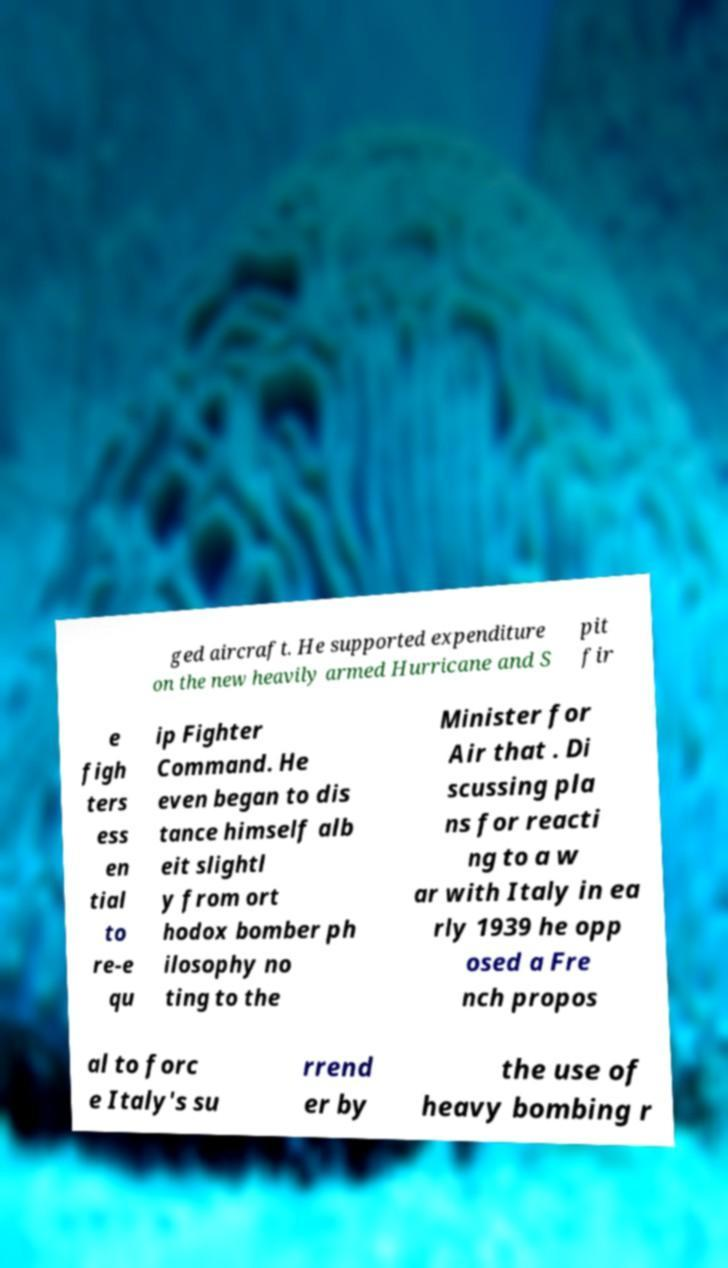Can you read and provide the text displayed in the image?This photo seems to have some interesting text. Can you extract and type it out for me? ged aircraft. He supported expenditure on the new heavily armed Hurricane and S pit fir e figh ters ess en tial to re-e qu ip Fighter Command. He even began to dis tance himself alb eit slightl y from ort hodox bomber ph ilosophy no ting to the Minister for Air that . Di scussing pla ns for reacti ng to a w ar with Italy in ea rly 1939 he opp osed a Fre nch propos al to forc e Italy's su rrend er by the use of heavy bombing r 